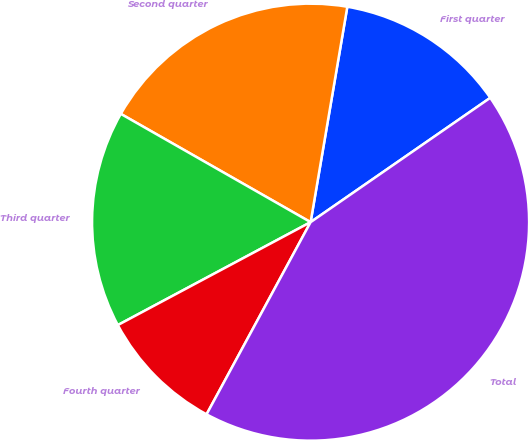Convert chart to OTSL. <chart><loc_0><loc_0><loc_500><loc_500><pie_chart><fcel>First quarter<fcel>Second quarter<fcel>Third quarter<fcel>Fourth quarter<fcel>Total<nl><fcel>12.68%<fcel>19.44%<fcel>16.06%<fcel>9.3%<fcel>42.54%<nl></chart> 